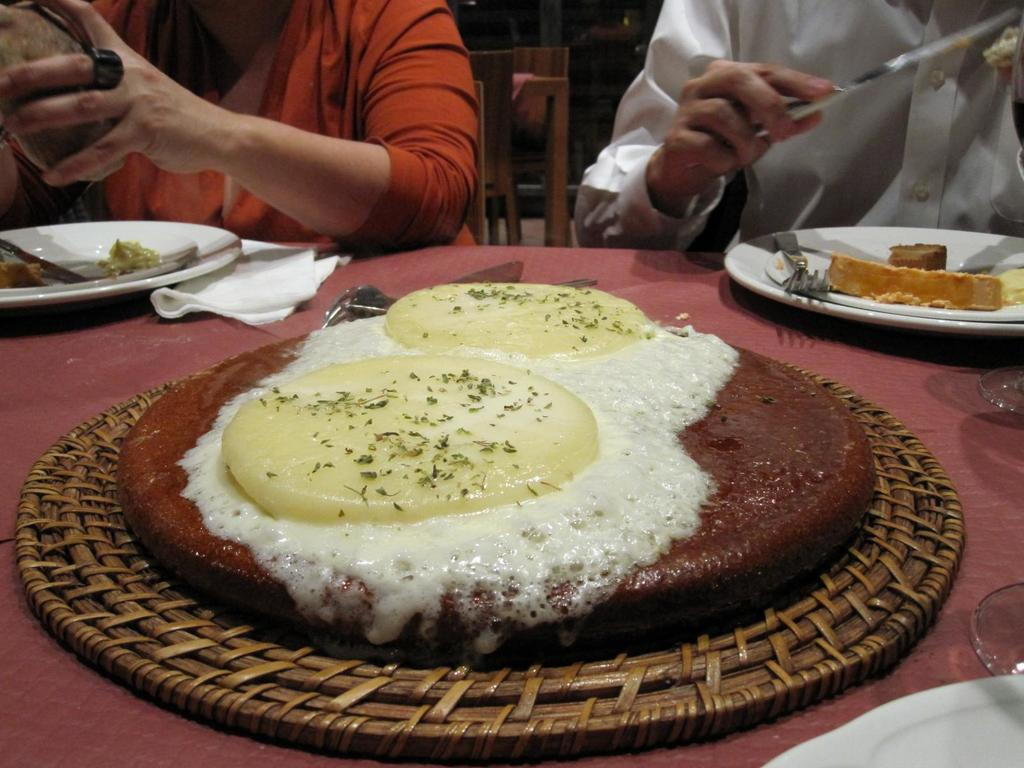What can be seen in the image related to food? There are food items in the image. How many people are present in the image? There are two people in the image. What type of respect can be seen in the image? There is no indication of respect in the image, as it only features food items and two people. How many flies are present in the image? There is no mention of flies in the image, so it is not possible to determine their number. 